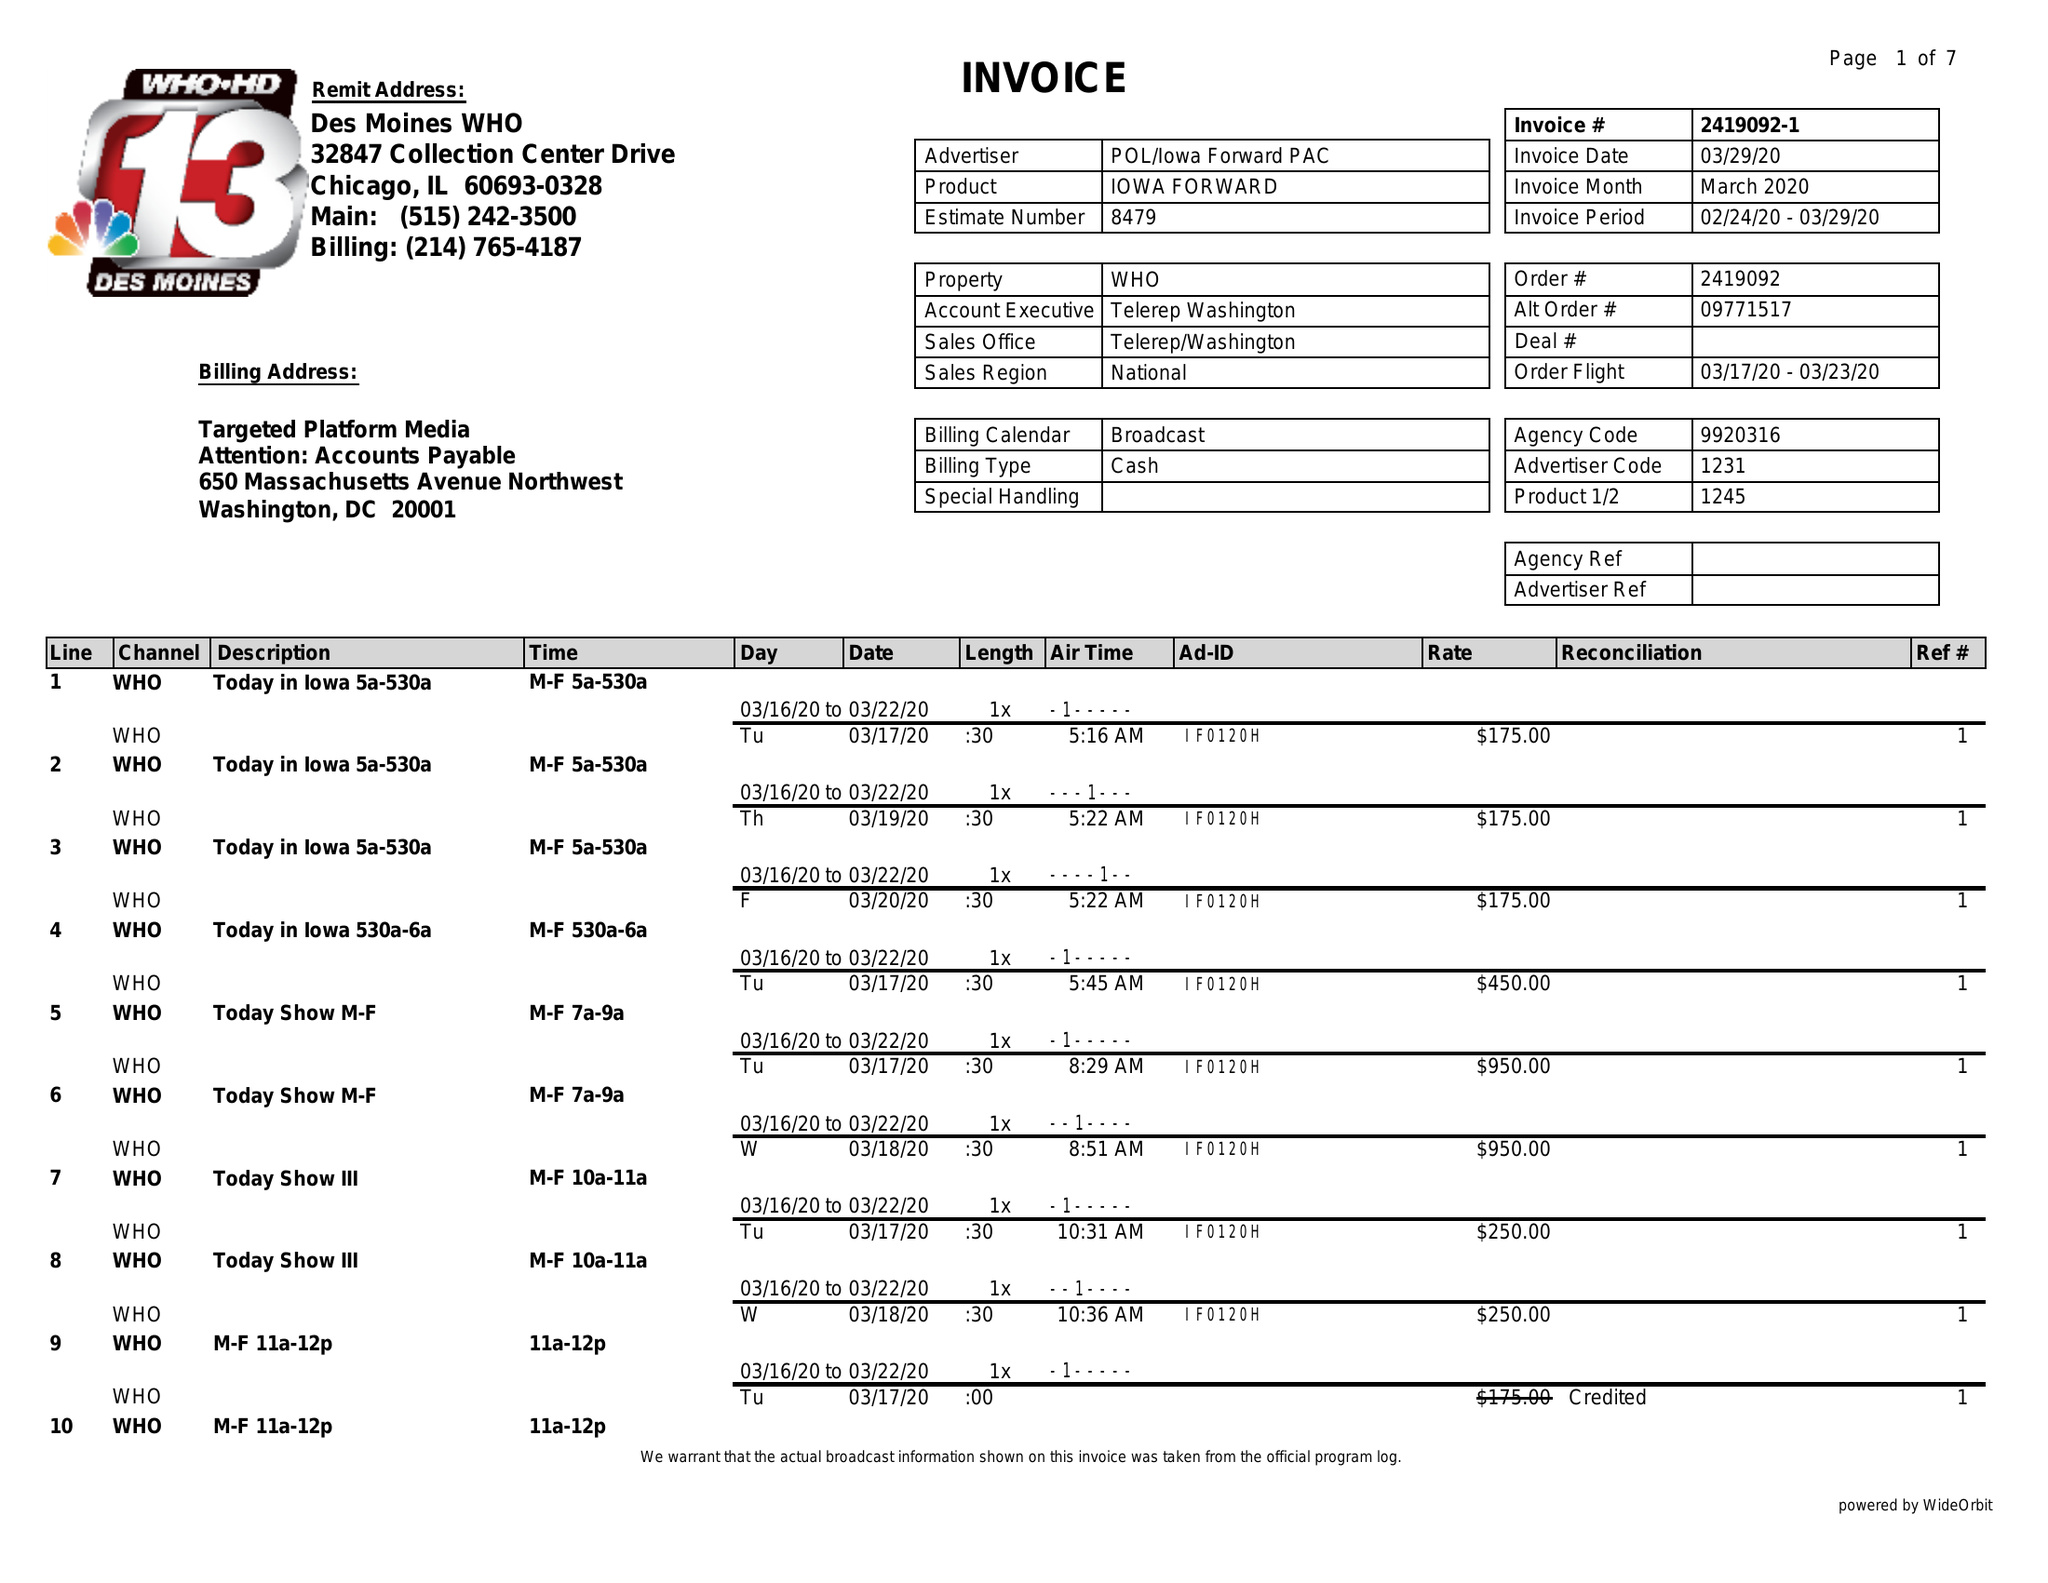What is the value for the flight_to?
Answer the question using a single word or phrase. 03/23/20 